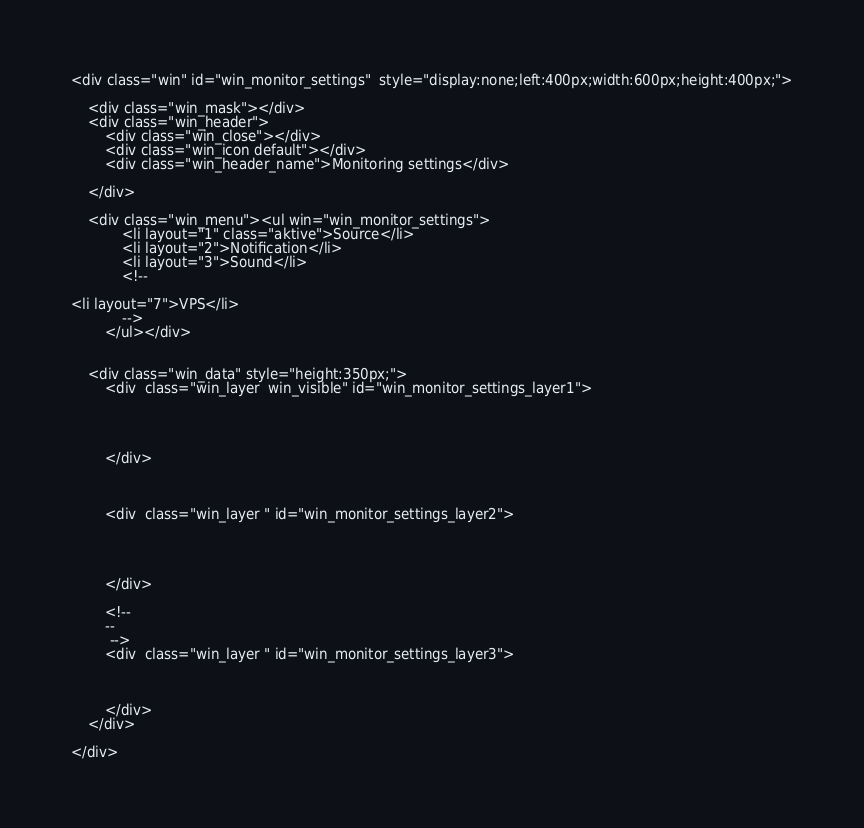Convert code to text. <code><loc_0><loc_0><loc_500><loc_500><_PHP_><div class="win" id="win_monitor_settings"  style="display:none;left:400px;width:600px;height:400px;">

    <div class="win_mask"></div>
    <div class="win_header">
        <div class="win_close"></div>
        <div class="win_icon default"></div>
        <div class="win_header_name">Monitoring settings</div>

    </div>

    <div class="win_menu"><ul win="win_monitor_settings">
            <li layout="1" class="aktive">Source</li>
            <li layout="2">Notification</li>
            <li layout="3">Sound</li>
            <!-- 

<li layout="7">VPS</li>
            -->
        </ul></div>


    <div class="win_data" style="height:350px;">		
        <div  class="win_layer  win_visible" id="win_monitor_settings_layer1">




        </div>



        <div  class="win_layer " id="win_monitor_settings_layer2">




        </div>

        <!-- 
        --
         -->
        <div  class="win_layer " id="win_monitor_settings_layer3">



        </div>
    </div>

</div></code> 